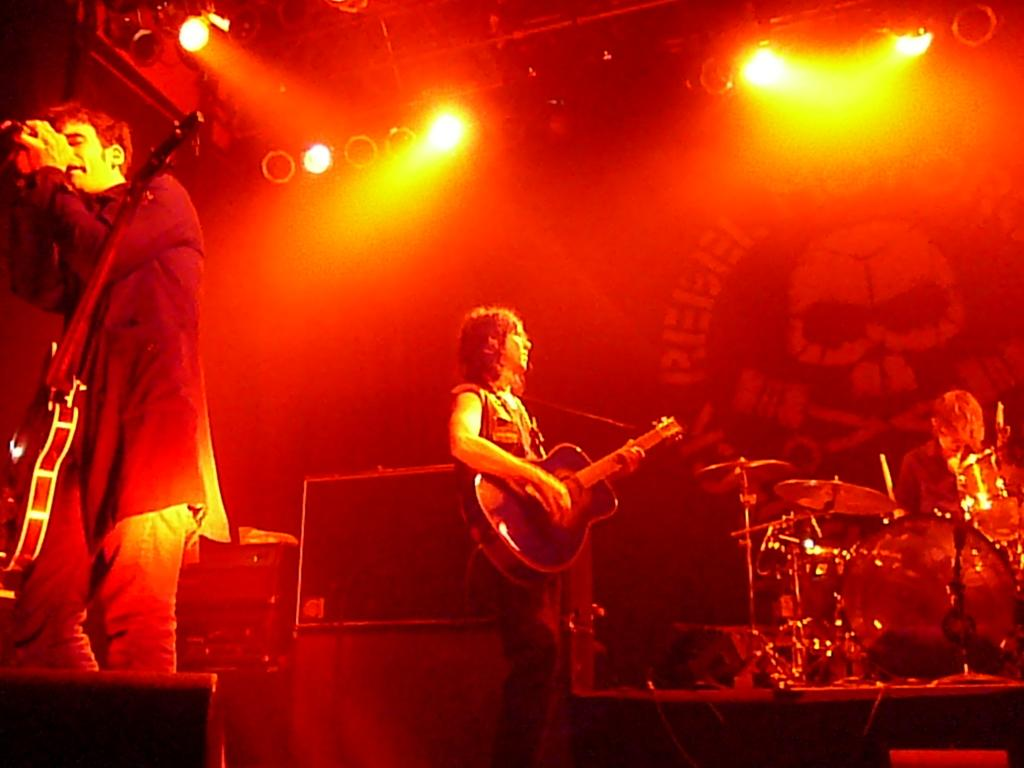What is the person in the image doing? The person in the image is standing and playing the guitar. What musical instrument is visible near the person playing the guitar? There are drums visible in the image. Is there another person in the image? Yes, there is another person standing near the drums in the image. What can be seen in the background or surroundings of the image? There are lights in the image. How many trees are visible in the image? There are no trees visible in the image. What type of flesh can be seen on the person playing the guitar? There is no flesh visible on the person playing the guitar in the image, as the person is fully clothed. 